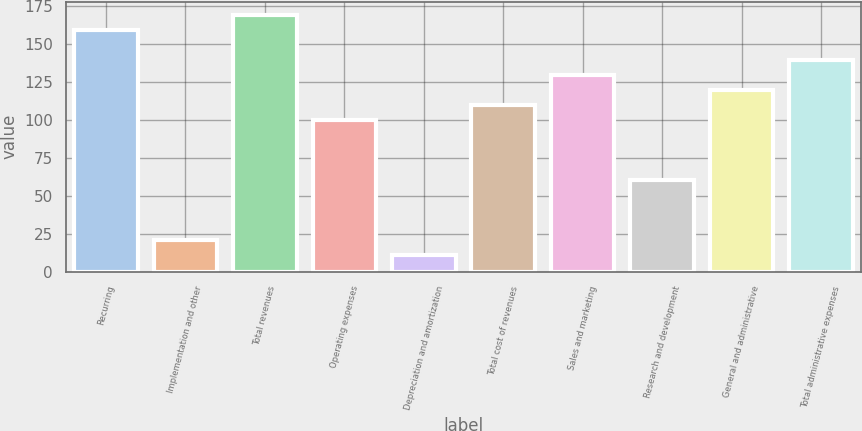<chart> <loc_0><loc_0><loc_500><loc_500><bar_chart><fcel>Recurring<fcel>Implementation and other<fcel>Total revenues<fcel>Operating expenses<fcel>Depreciation and amortization<fcel>Total cost of revenues<fcel>Sales and marketing<fcel>Research and development<fcel>General and administrative<fcel>Total administrative expenses<nl><fcel>159.4<fcel>20.8<fcel>169.3<fcel>100<fcel>10.9<fcel>109.9<fcel>129.7<fcel>60.4<fcel>119.8<fcel>139.6<nl></chart> 